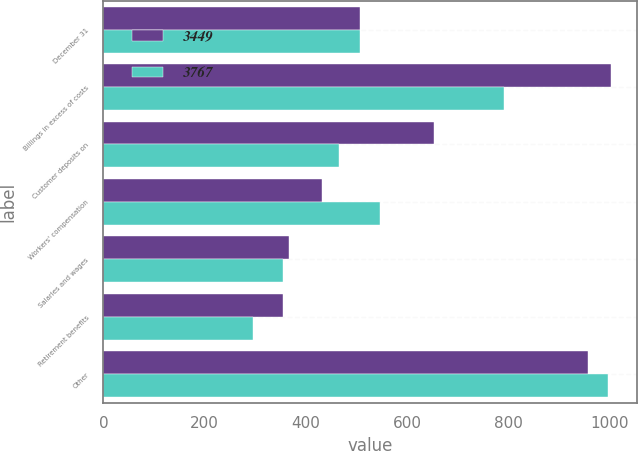<chart> <loc_0><loc_0><loc_500><loc_500><stacked_bar_chart><ecel><fcel>December 31<fcel>Billings in excess of costs<fcel>Customer deposits on<fcel>Workers' compensation<fcel>Salaries and wages<fcel>Retirement benefits<fcel>Other<nl><fcel>3449<fcel>506<fcel>1003<fcel>653<fcel>432<fcel>367<fcel>355<fcel>957<nl><fcel>3767<fcel>506<fcel>791<fcel>465<fcel>547<fcel>355<fcel>295<fcel>996<nl></chart> 